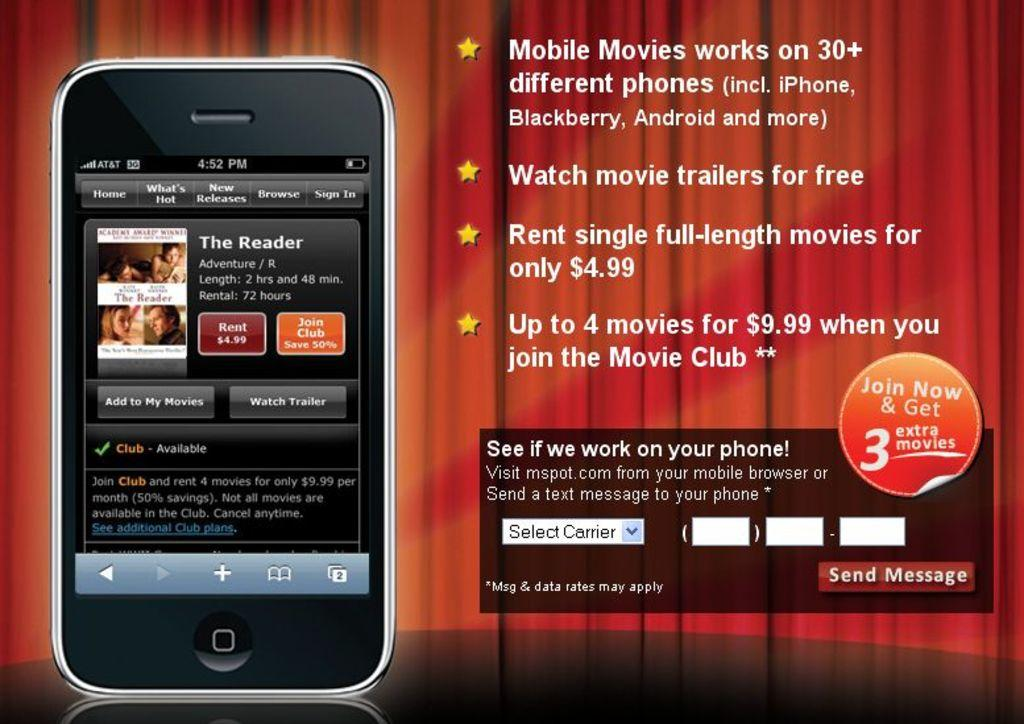<image>
Describe the image concisely. An advertisement for a movie streaming service that lets people watch movie trailers for free. 